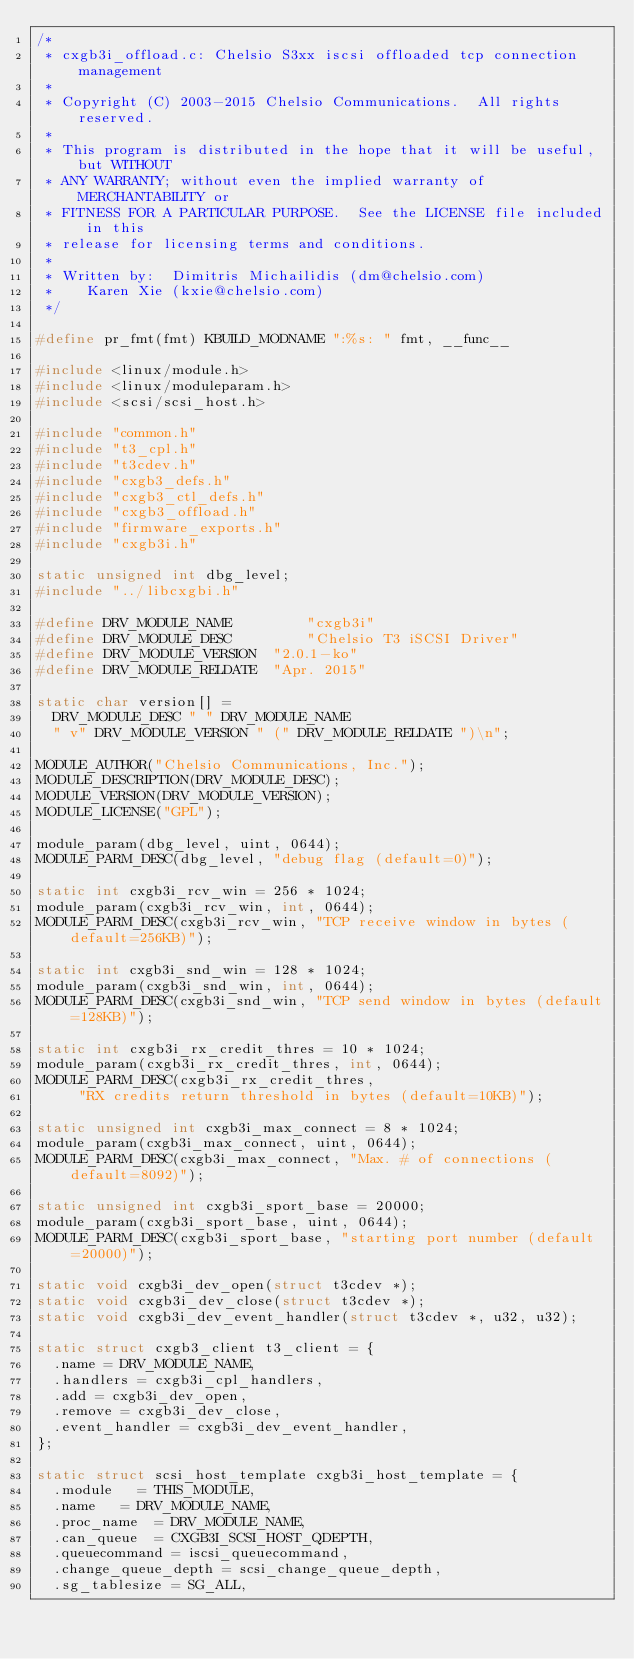Convert code to text. <code><loc_0><loc_0><loc_500><loc_500><_C_>/*
 * cxgb3i_offload.c: Chelsio S3xx iscsi offloaded tcp connection management
 *
 * Copyright (C) 2003-2015 Chelsio Communications.  All rights reserved.
 *
 * This program is distributed in the hope that it will be useful, but WITHOUT
 * ANY WARRANTY; without even the implied warranty of MERCHANTABILITY or
 * FITNESS FOR A PARTICULAR PURPOSE.  See the LICENSE file included in this
 * release for licensing terms and conditions.
 *
 * Written by:	Dimitris Michailidis (dm@chelsio.com)
 *		Karen Xie (kxie@chelsio.com)
 */

#define pr_fmt(fmt) KBUILD_MODNAME ":%s: " fmt, __func__

#include <linux/module.h>
#include <linux/moduleparam.h>
#include <scsi/scsi_host.h>

#include "common.h"
#include "t3_cpl.h"
#include "t3cdev.h"
#include "cxgb3_defs.h"
#include "cxgb3_ctl_defs.h"
#include "cxgb3_offload.h"
#include "firmware_exports.h"
#include "cxgb3i.h"

static unsigned int dbg_level;
#include "../libcxgbi.h"

#define DRV_MODULE_NAME         "cxgb3i"
#define DRV_MODULE_DESC         "Chelsio T3 iSCSI Driver"
#define DRV_MODULE_VERSION	"2.0.1-ko"
#define DRV_MODULE_RELDATE	"Apr. 2015"

static char version[] =
	DRV_MODULE_DESC " " DRV_MODULE_NAME
	" v" DRV_MODULE_VERSION " (" DRV_MODULE_RELDATE ")\n";

MODULE_AUTHOR("Chelsio Communications, Inc.");
MODULE_DESCRIPTION(DRV_MODULE_DESC);
MODULE_VERSION(DRV_MODULE_VERSION);
MODULE_LICENSE("GPL");

module_param(dbg_level, uint, 0644);
MODULE_PARM_DESC(dbg_level, "debug flag (default=0)");

static int cxgb3i_rcv_win = 256 * 1024;
module_param(cxgb3i_rcv_win, int, 0644);
MODULE_PARM_DESC(cxgb3i_rcv_win, "TCP receive window in bytes (default=256KB)");

static int cxgb3i_snd_win = 128 * 1024;
module_param(cxgb3i_snd_win, int, 0644);
MODULE_PARM_DESC(cxgb3i_snd_win, "TCP send window in bytes (default=128KB)");

static int cxgb3i_rx_credit_thres = 10 * 1024;
module_param(cxgb3i_rx_credit_thres, int, 0644);
MODULE_PARM_DESC(cxgb3i_rx_credit_thres,
		 "RX credits return threshold in bytes (default=10KB)");

static unsigned int cxgb3i_max_connect = 8 * 1024;
module_param(cxgb3i_max_connect, uint, 0644);
MODULE_PARM_DESC(cxgb3i_max_connect, "Max. # of connections (default=8092)");

static unsigned int cxgb3i_sport_base = 20000;
module_param(cxgb3i_sport_base, uint, 0644);
MODULE_PARM_DESC(cxgb3i_sport_base, "starting port number (default=20000)");

static void cxgb3i_dev_open(struct t3cdev *);
static void cxgb3i_dev_close(struct t3cdev *);
static void cxgb3i_dev_event_handler(struct t3cdev *, u32, u32);

static struct cxgb3_client t3_client = {
	.name = DRV_MODULE_NAME,
	.handlers = cxgb3i_cpl_handlers,
	.add = cxgb3i_dev_open,
	.remove = cxgb3i_dev_close,
	.event_handler = cxgb3i_dev_event_handler,
};

static struct scsi_host_template cxgb3i_host_template = {
	.module		= THIS_MODULE,
	.name		= DRV_MODULE_NAME,
	.proc_name	= DRV_MODULE_NAME,
	.can_queue	= CXGB3I_SCSI_HOST_QDEPTH,
	.queuecommand	= iscsi_queuecommand,
	.change_queue_depth = scsi_change_queue_depth,
	.sg_tablesize	= SG_ALL,</code> 